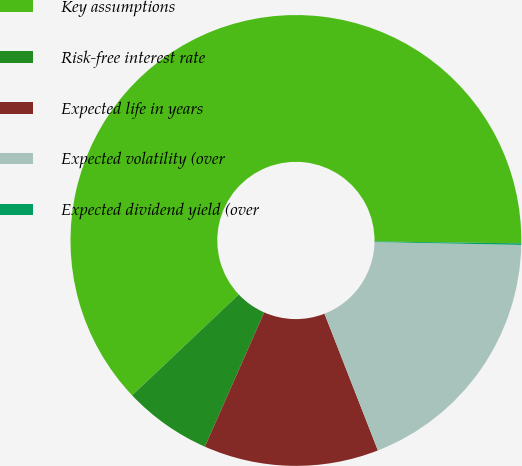<chart> <loc_0><loc_0><loc_500><loc_500><pie_chart><fcel>Key assumptions<fcel>Risk-free interest rate<fcel>Expected life in years<fcel>Expected volatility (over<fcel>Expected dividend yield (over<nl><fcel>62.26%<fcel>6.33%<fcel>12.54%<fcel>18.76%<fcel>0.11%<nl></chart> 